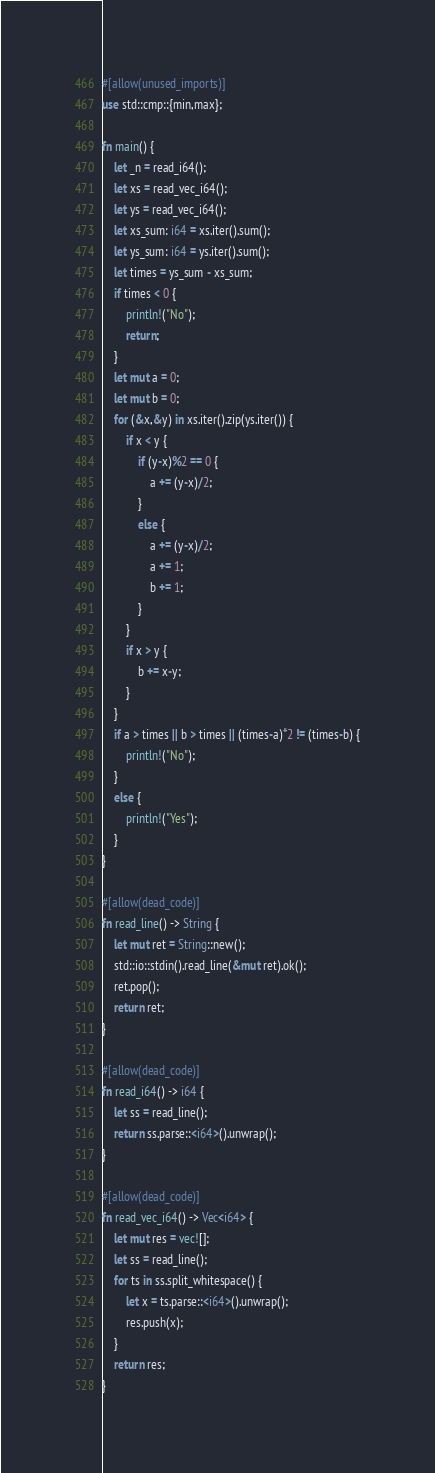<code> <loc_0><loc_0><loc_500><loc_500><_Rust_>#[allow(unused_imports)]
use std::cmp::{min,max};

fn main() {
    let _n = read_i64();
    let xs = read_vec_i64();
    let ys = read_vec_i64();
    let xs_sum: i64 = xs.iter().sum();
    let ys_sum: i64 = ys.iter().sum();
    let times = ys_sum - xs_sum;
    if times < 0 {
        println!("No");
        return;
    }
    let mut a = 0;
    let mut b = 0;
    for (&x,&y) in xs.iter().zip(ys.iter()) {
        if x < y {
            if (y-x)%2 == 0 {
                a += (y-x)/2;
            }
            else {
                a += (y-x)/2;
                a += 1;
                b += 1;
            }
        }
        if x > y {
            b += x-y;
        }
    }
    if a > times || b > times || (times-a)*2 != (times-b) {
        println!("No");
    }
    else {
        println!("Yes");
    }
}

#[allow(dead_code)]
fn read_line() -> String {
    let mut ret = String::new();
    std::io::stdin().read_line(&mut ret).ok();
    ret.pop();
    return ret;
}

#[allow(dead_code)]
fn read_i64() -> i64 {
    let ss = read_line();
    return ss.parse::<i64>().unwrap();
}

#[allow(dead_code)]
fn read_vec_i64() -> Vec<i64> {
    let mut res = vec![];
    let ss = read_line();
    for ts in ss.split_whitespace() {
        let x = ts.parse::<i64>().unwrap();
        res.push(x);
    }
    return res;
}
</code> 